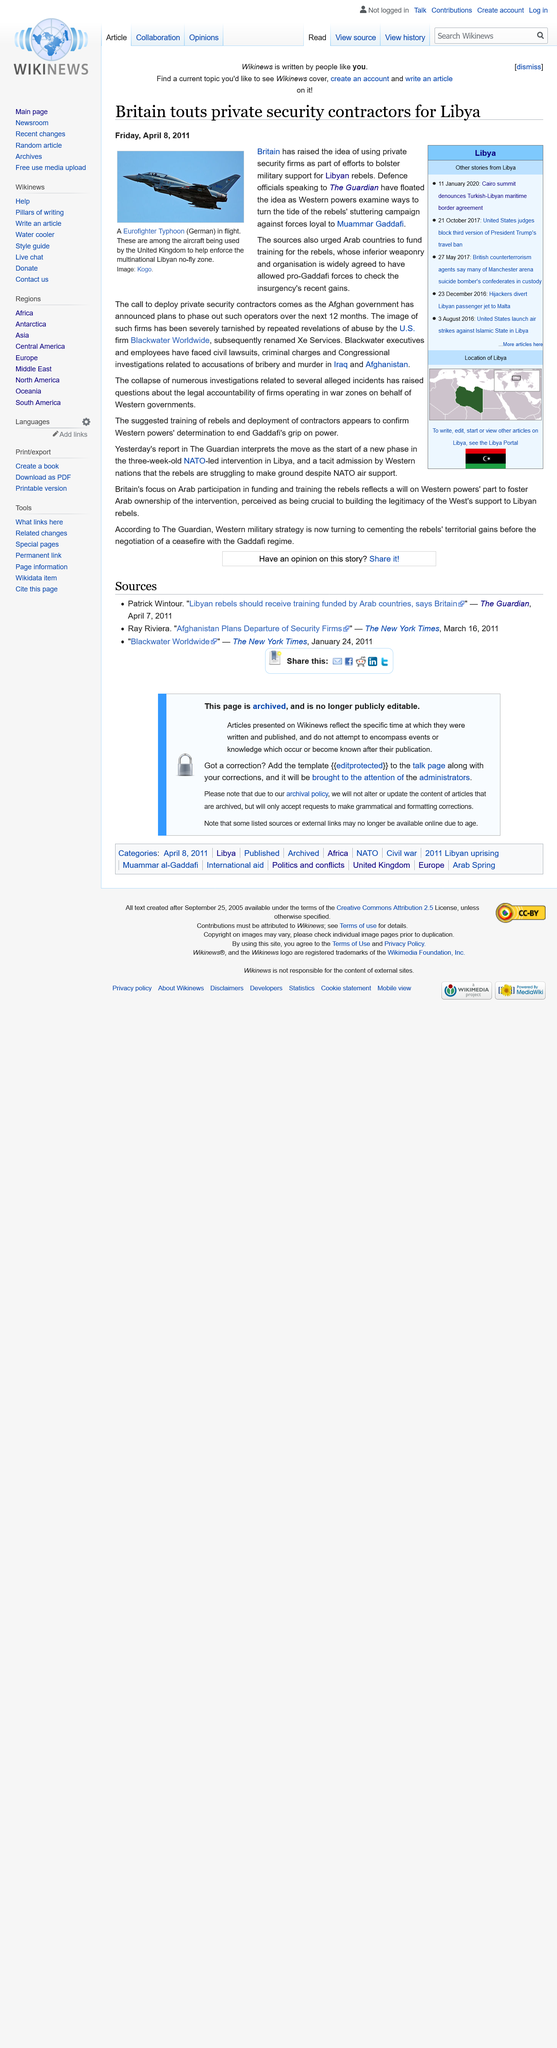Draw attention to some important aspects in this diagram. Britain has proposed using private security firms to augment military support for Libyan rebels. The Eurofighter Typhoon aircraft is pictured and the image was supplied by Kogo. NATO is providing air support to the rebels. 